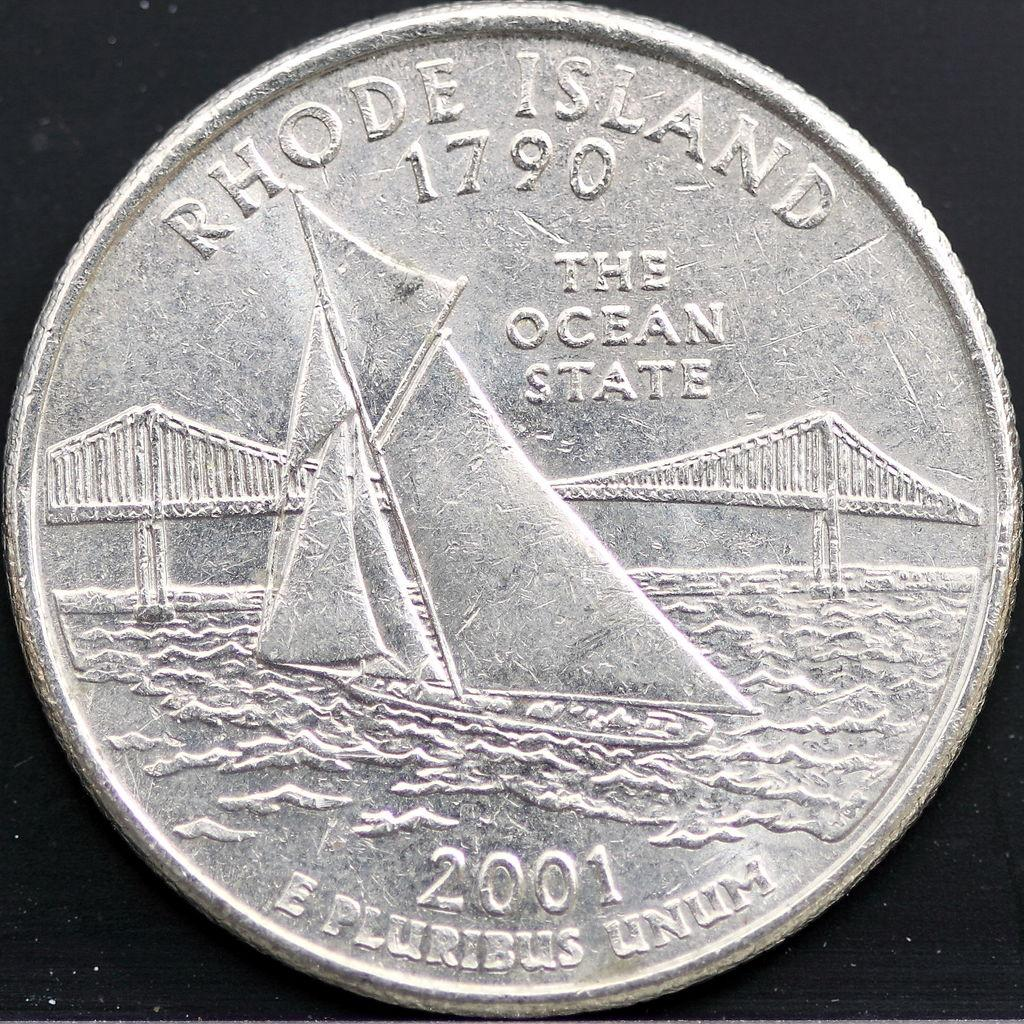Provide a one-sentence caption for the provided image. The back of a 2001 quarter features a bridge and a sailboat. 